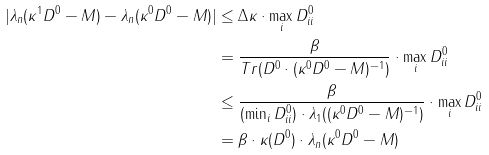<formula> <loc_0><loc_0><loc_500><loc_500>| \lambda _ { n } ( \kappa ^ { 1 } D ^ { 0 } - M ) - \lambda _ { n } ( \kappa ^ { 0 } D ^ { 0 } - M ) | & \leq \Delta \kappa \cdot \max _ { i } D _ { i i } ^ { 0 } \\ & = \frac { \beta } { T r ( D ^ { 0 } \cdot ( \kappa ^ { 0 } D ^ { 0 } - M ) ^ { - 1 } ) } \cdot \max _ { i } D _ { i i } ^ { 0 } \\ & \leq \frac { \beta } { ( \min _ { i } D _ { i i } ^ { 0 } ) \cdot \lambda _ { 1 } ( ( \kappa ^ { 0 } D ^ { 0 } - M ) ^ { - 1 } ) } \cdot \max _ { i } D _ { i i } ^ { 0 } \\ & = \beta \cdot \kappa ( D ^ { 0 } ) \cdot \lambda _ { n } ( \kappa ^ { 0 } D ^ { 0 } - M )</formula> 